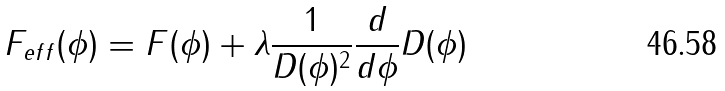Convert formula to latex. <formula><loc_0><loc_0><loc_500><loc_500>F _ { e f f } ( \phi ) = F ( \phi ) + \lambda \frac { 1 } { D ( \phi ) ^ { 2 } } \frac { d } { d \phi } D ( \phi )</formula> 